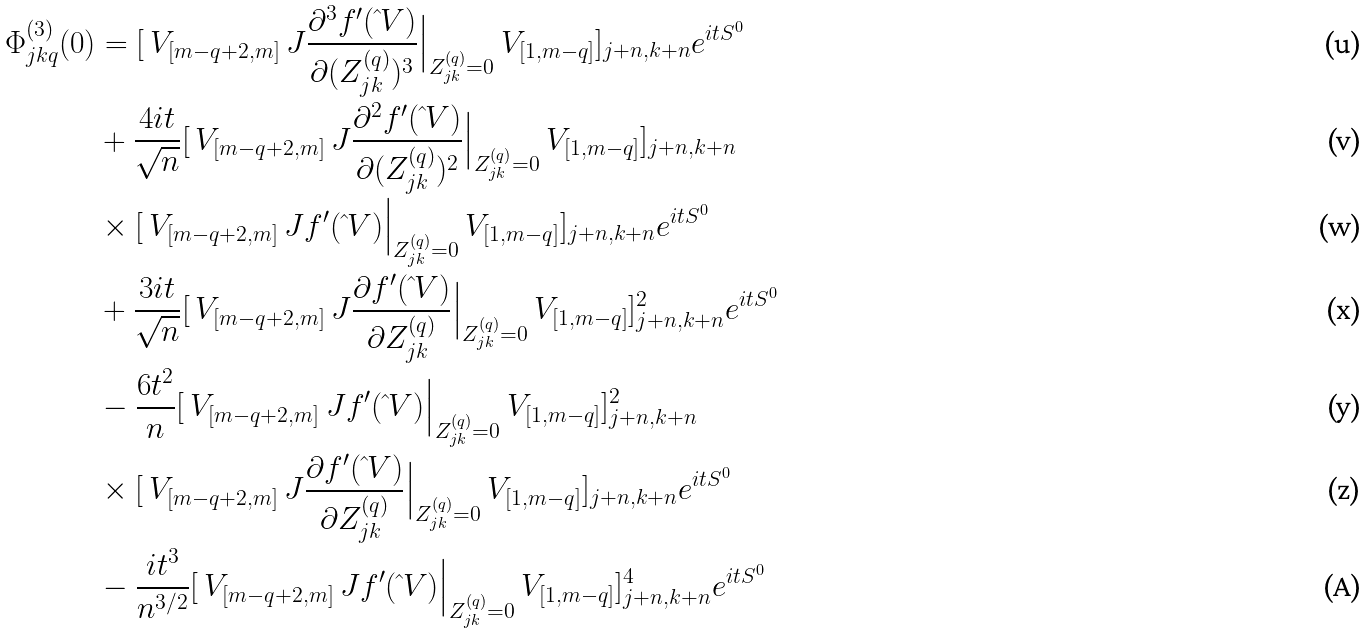<formula> <loc_0><loc_0><loc_500><loc_500>\Phi _ { j k q } ^ { ( 3 ) } ( 0 ) & = [ \ V _ { [ m - q + 2 , m ] } \ J \frac { \partial ^ { 3 } f ^ { \prime } ( \hat { \ } V ) } { \partial ( Z _ { j k } ^ { ( q ) } ) ^ { 3 } } \Big | _ { Z _ { j k } ^ { ( q ) } = 0 } \ V _ { [ 1 , m - q ] } ] _ { j + n , k + n } e ^ { i t S ^ { 0 } } \\ & + \frac { 4 i t } { \sqrt { n } } [ \ V _ { [ m - q + 2 , m ] } \ J \frac { \partial ^ { 2 } f ^ { \prime } ( \hat { \ } V ) } { \partial ( Z _ { j k } ^ { ( q ) } ) ^ { 2 } } \Big | _ { Z _ { j k } ^ { ( q ) } = 0 } \ V _ { [ 1 , m - q ] } ] _ { j + n , k + n } \\ & \times [ \ V _ { [ m - q + 2 , m ] } \ J f ^ { \prime } ( \hat { \ } V ) \Big | _ { Z _ { j k } ^ { ( q ) } = 0 } \ V _ { [ 1 , m - q ] } ] _ { j + n , k + n } e ^ { i t S ^ { 0 } } \\ & + \frac { 3 i t } { \sqrt { n } } [ \ V _ { [ m - q + 2 , m ] } \ J \frac { \partial f ^ { \prime } ( \hat { \ } V ) } { \partial Z _ { j k } ^ { ( q ) } } \Big | _ { Z _ { j k } ^ { ( q ) } = 0 } \ V _ { [ 1 , m - q ] } ] _ { j + n , k + n } ^ { 2 } e ^ { i t S ^ { 0 } } \\ & - \frac { 6 t ^ { 2 } } { n } [ \ V _ { [ m - q + 2 , m ] } \ J f ^ { \prime } ( \hat { \ } V ) \Big | _ { Z _ { j k } ^ { ( q ) } = 0 } \ V _ { [ 1 , m - q ] } ] _ { j + n , k + n } ^ { 2 } \\ & \times [ \ V _ { [ m - q + 2 , m ] } \ J \frac { \partial f ^ { \prime } ( \hat { \ } V ) } { \partial Z _ { j k } ^ { ( q ) } } \Big | _ { Z _ { j k } ^ { ( q ) } = 0 } \ V _ { [ 1 , m - q ] } ] _ { j + n , k + n } e ^ { i t S ^ { 0 } } \\ & - \frac { i t ^ { 3 } } { n ^ { 3 / 2 } } [ \ V _ { [ m - q + 2 , m ] } \ J f ^ { \prime } ( \hat { \ } V ) \Big | _ { Z _ { j k } ^ { ( q ) } = 0 } \ V _ { [ 1 , m - q ] } ] _ { j + n , k + n } ^ { 4 } e ^ { i t S ^ { 0 } }</formula> 